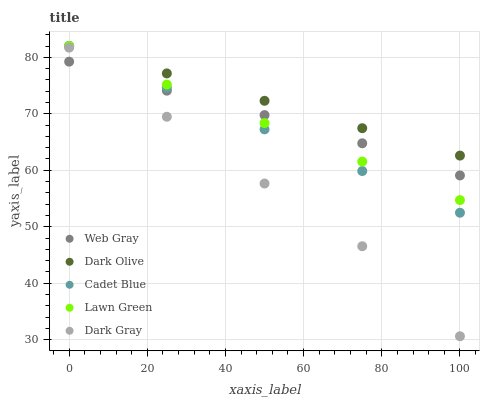Does Dark Gray have the minimum area under the curve?
Answer yes or no. Yes. Does Dark Olive have the maximum area under the curve?
Answer yes or no. Yes. Does Lawn Green have the minimum area under the curve?
Answer yes or no. No. Does Lawn Green have the maximum area under the curve?
Answer yes or no. No. Is Dark Olive the smoothest?
Answer yes or no. Yes. Is Dark Gray the roughest?
Answer yes or no. Yes. Is Lawn Green the smoothest?
Answer yes or no. No. Is Lawn Green the roughest?
Answer yes or no. No. Does Dark Gray have the lowest value?
Answer yes or no. Yes. Does Lawn Green have the lowest value?
Answer yes or no. No. Does Cadet Blue have the highest value?
Answer yes or no. Yes. Does Web Gray have the highest value?
Answer yes or no. No. Is Dark Gray less than Dark Olive?
Answer yes or no. Yes. Is Dark Olive greater than Web Gray?
Answer yes or no. Yes. Does Cadet Blue intersect Dark Olive?
Answer yes or no. Yes. Is Cadet Blue less than Dark Olive?
Answer yes or no. No. Is Cadet Blue greater than Dark Olive?
Answer yes or no. No. Does Dark Gray intersect Dark Olive?
Answer yes or no. No. 